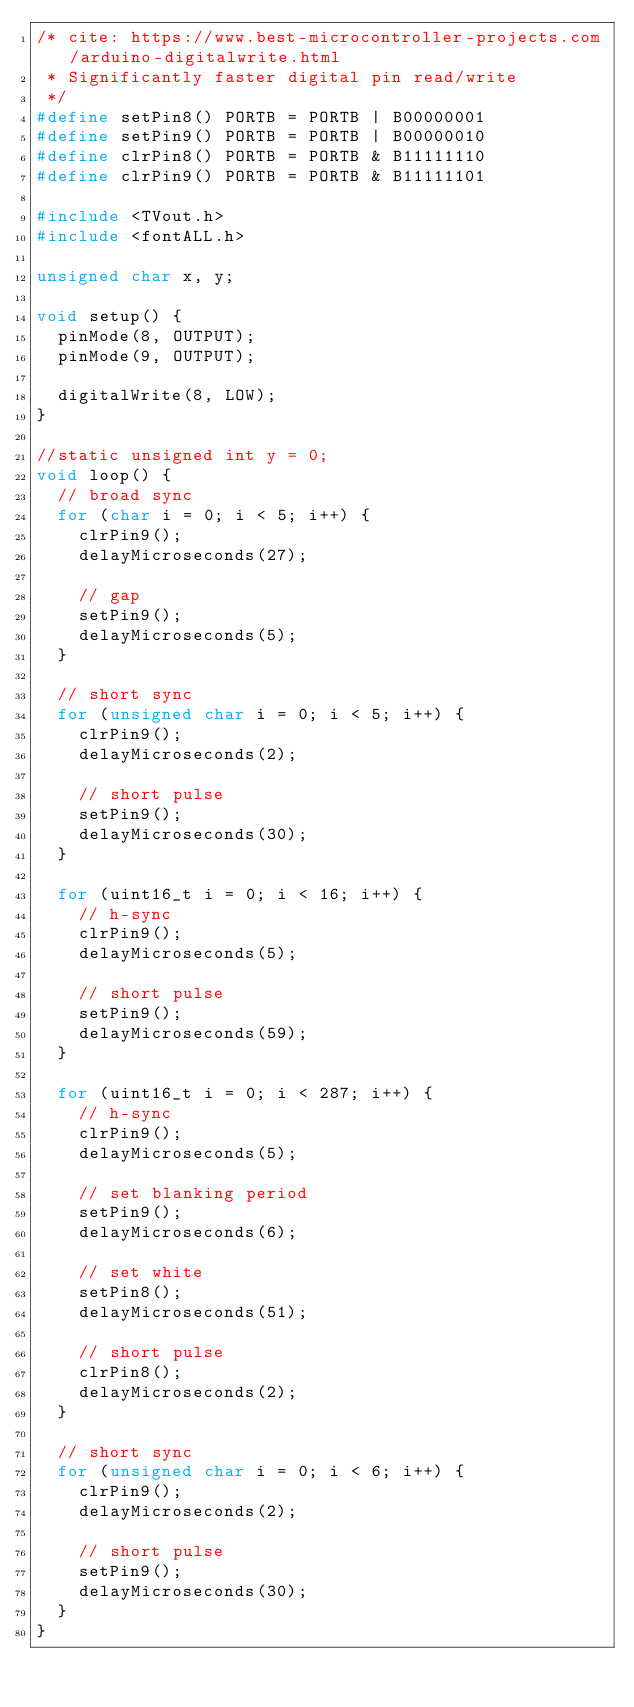Convert code to text. <code><loc_0><loc_0><loc_500><loc_500><_C++_>/* cite: https://www.best-microcontroller-projects.com/arduino-digitalwrite.html
 * Significantly faster digital pin read/write
 */
#define setPin8() PORTB = PORTB | B00000001
#define setPin9() PORTB = PORTB | B00000010
#define clrPin8() PORTB = PORTB & B11111110
#define clrPin9() PORTB = PORTB & B11111101

#include <TVout.h>
#include <fontALL.h>

unsigned char x, y;

void setup() {
  pinMode(8, OUTPUT);
  pinMode(9, OUTPUT);

  digitalWrite(8, LOW);
}

//static unsigned int y = 0;
void loop() {
  // broad sync
  for (char i = 0; i < 5; i++) {
    clrPin9();
    delayMicroseconds(27);

    // gap
    setPin9();
    delayMicroseconds(5);
  }

  // short sync
  for (unsigned char i = 0; i < 5; i++) {
    clrPin9();
    delayMicroseconds(2);

    // short pulse
    setPin9();
    delayMicroseconds(30);
  }

  for (uint16_t i = 0; i < 16; i++) {
    // h-sync
    clrPin9();
    delayMicroseconds(5);

    // short pulse
    setPin9();
    delayMicroseconds(59);
  }

  for (uint16_t i = 0; i < 287; i++) {
    // h-sync
    clrPin9();
    delayMicroseconds(5);

    // set blanking period
    setPin9();
    delayMicroseconds(6);

    // set white
    setPin8();
    delayMicroseconds(51);

    // short pulse
    clrPin8();
    delayMicroseconds(2);
  }

  // short sync
  for (unsigned char i = 0; i < 6; i++) {
    clrPin9();
    delayMicroseconds(2);

    // short pulse
    setPin9();
    delayMicroseconds(30);
  }
}
</code> 